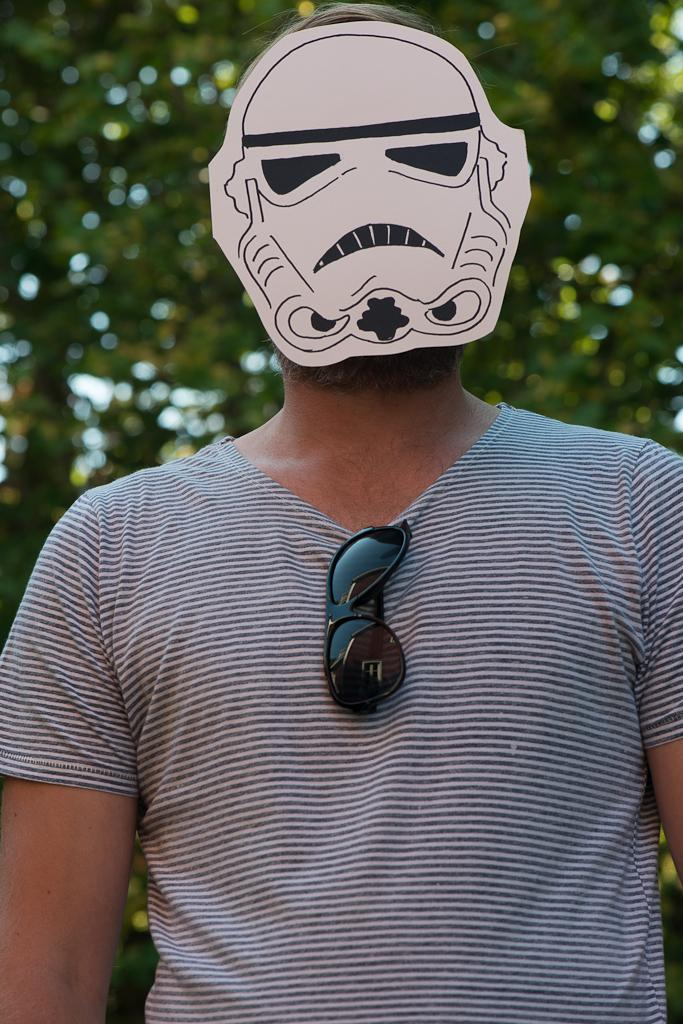Where was the image taken? The image is taken outdoors. What can be seen in the background of the image? There are trees with green leaves in the background. Who is the main subject in the image? There is a man in the middle of the image. What is the man wearing on his face? The man is wearing a mask on his face. What type of beast can be seen in the image? There is no beast present in the image; it features a man wearing a mask outdoors. What kind of treatment is being administered to the man in the image? There is no treatment being administered to the man in the image; he is simply wearing a mask. 